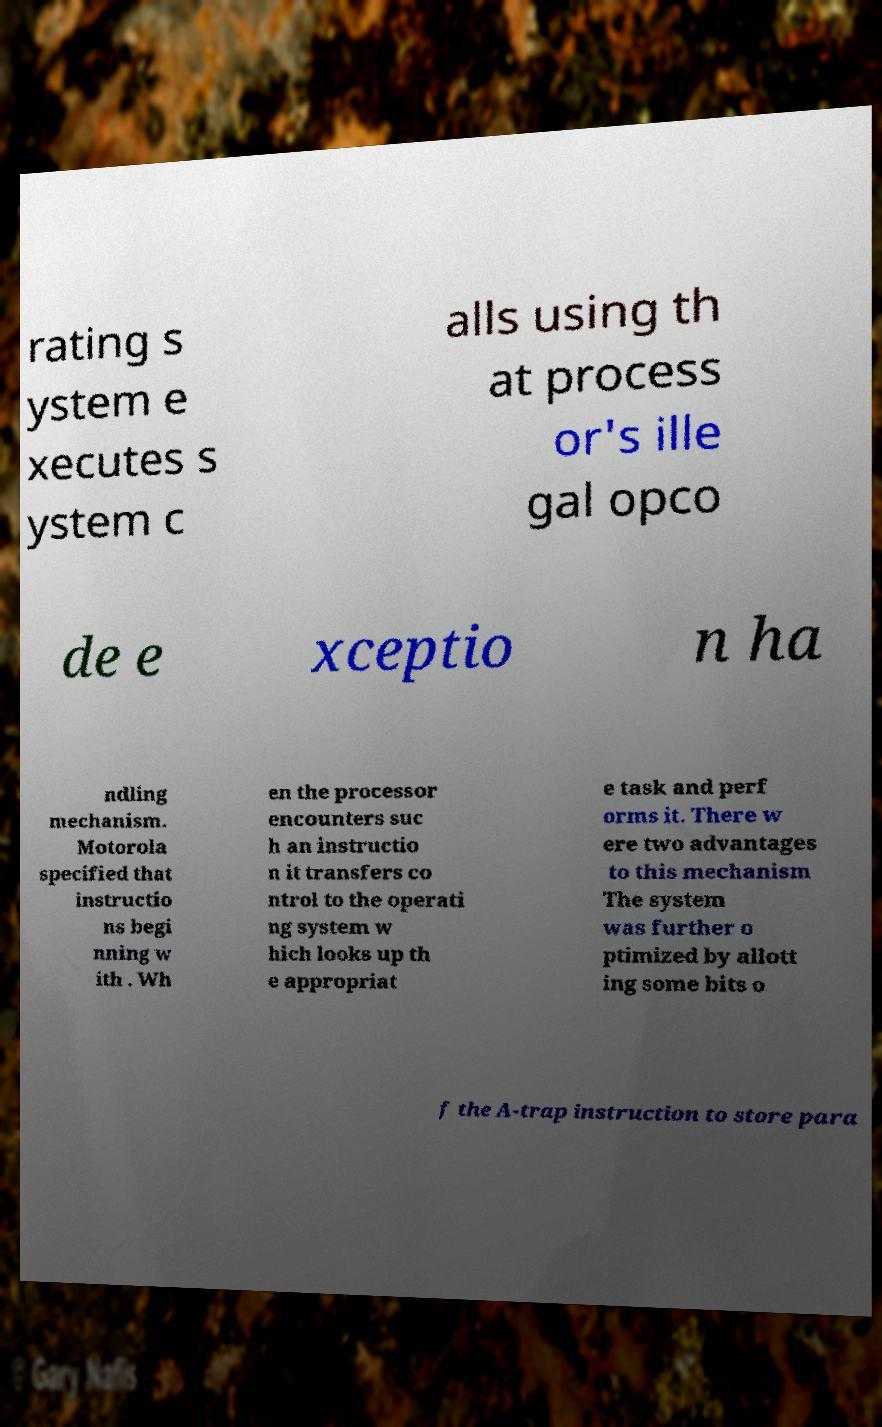Can you read and provide the text displayed in the image?This photo seems to have some interesting text. Can you extract and type it out for me? rating s ystem e xecutes s ystem c alls using th at process or's ille gal opco de e xceptio n ha ndling mechanism. Motorola specified that instructio ns begi nning w ith . Wh en the processor encounters suc h an instructio n it transfers co ntrol to the operati ng system w hich looks up th e appropriat e task and perf orms it. There w ere two advantages to this mechanism The system was further o ptimized by allott ing some bits o f the A-trap instruction to store para 